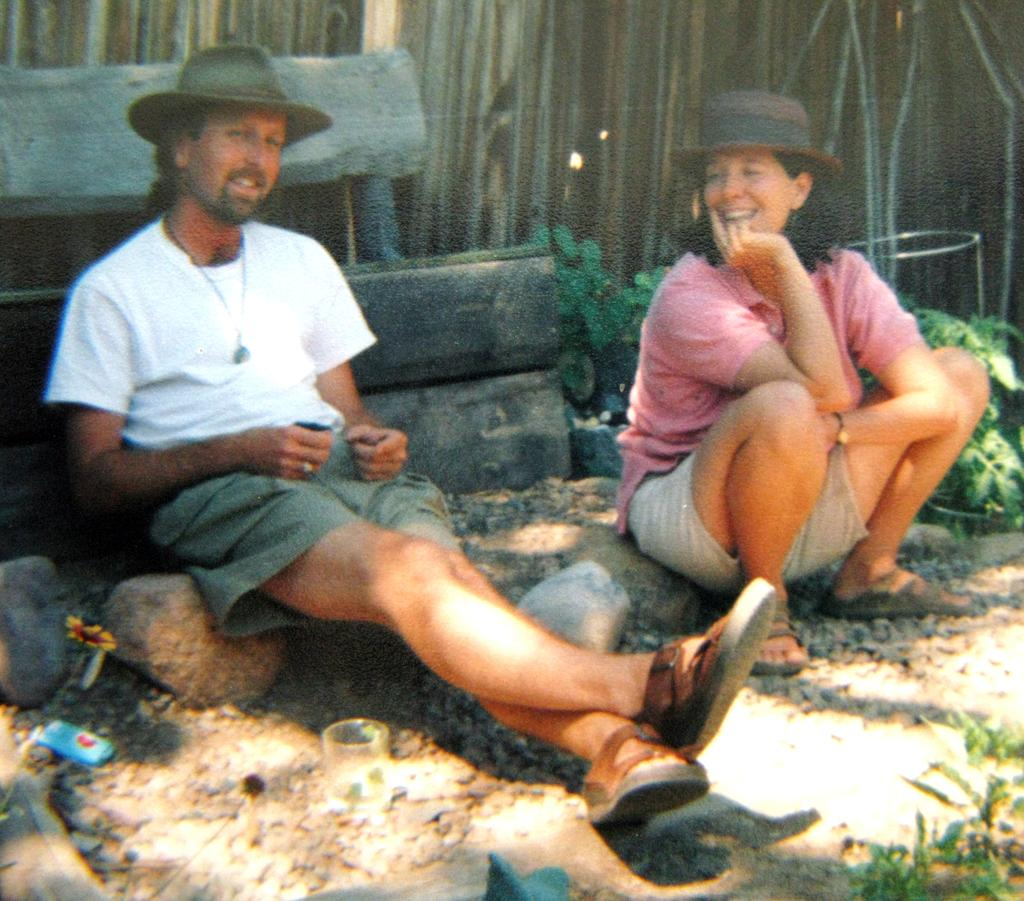How many people are sitting in the image? There are two people sitting in the image. What are the people wearing on their heads? The people are wearing caps. What colors are the dresses of the two people? The people are wearing different color dresses. What type of natural elements can be seen in the image? There are stones and green plants visible in the image. What is the background of the image like? The background of the image has multiple colors. Can you see any icicles hanging from the caps in the image? No, there are no icicles visible in the image. What type of transport is being used by the people in the image? There is no transport visible in the image; the people are sitting. Is there an oven present in the image? No, there is no oven present in the image. 